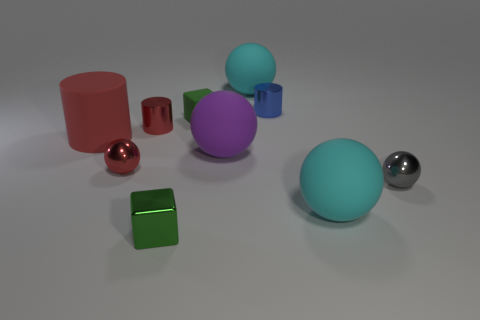How does the lighting in the image suggest the texture of the materials? The lighting in the image is soft and diffused, creating subtle shadows under the objects. The red and crimson cylinders have a matte finish as indicated by the muted reflection and scattered light. The spheres, however, particularly the silver one, display a higher reflectivity, suggesting a smoother and perhaps metallic texture. The green prism also has a slightly reflective surface, with highlight lines that reveal a smooth texture. The nature of the lighting brings out these textural details quite effectively. 